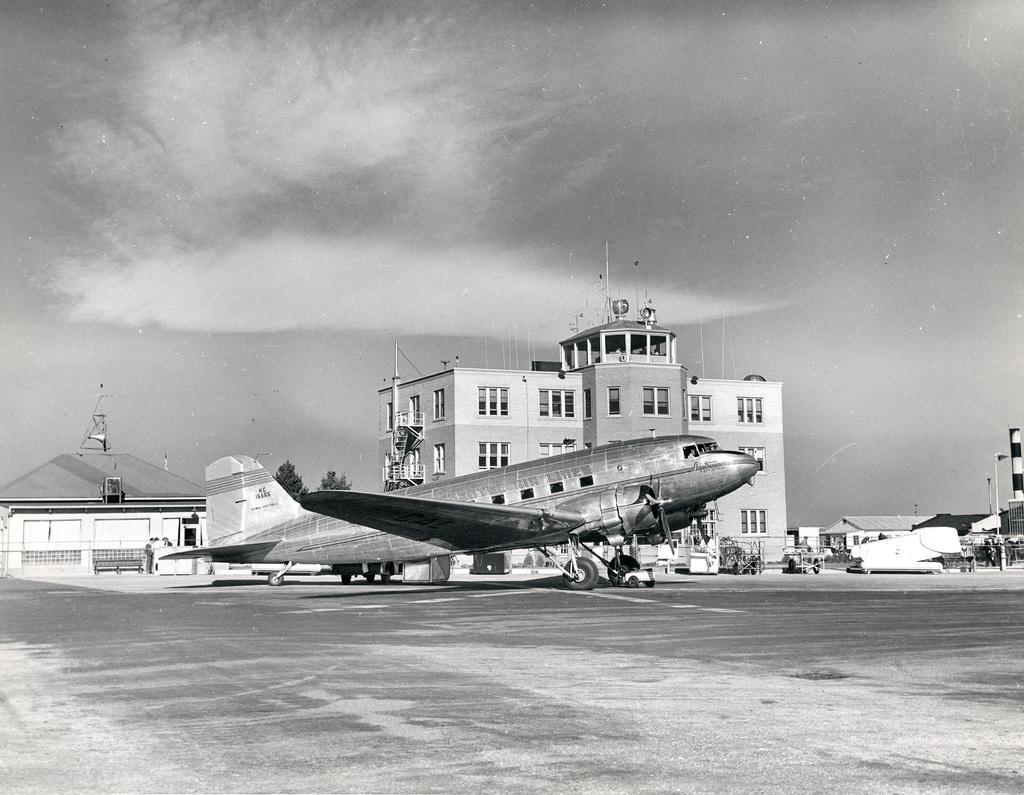Can you describe this image briefly? In this image there is an aeroplane at the center. At the background there are buildings, trees and at the top there is sky. 